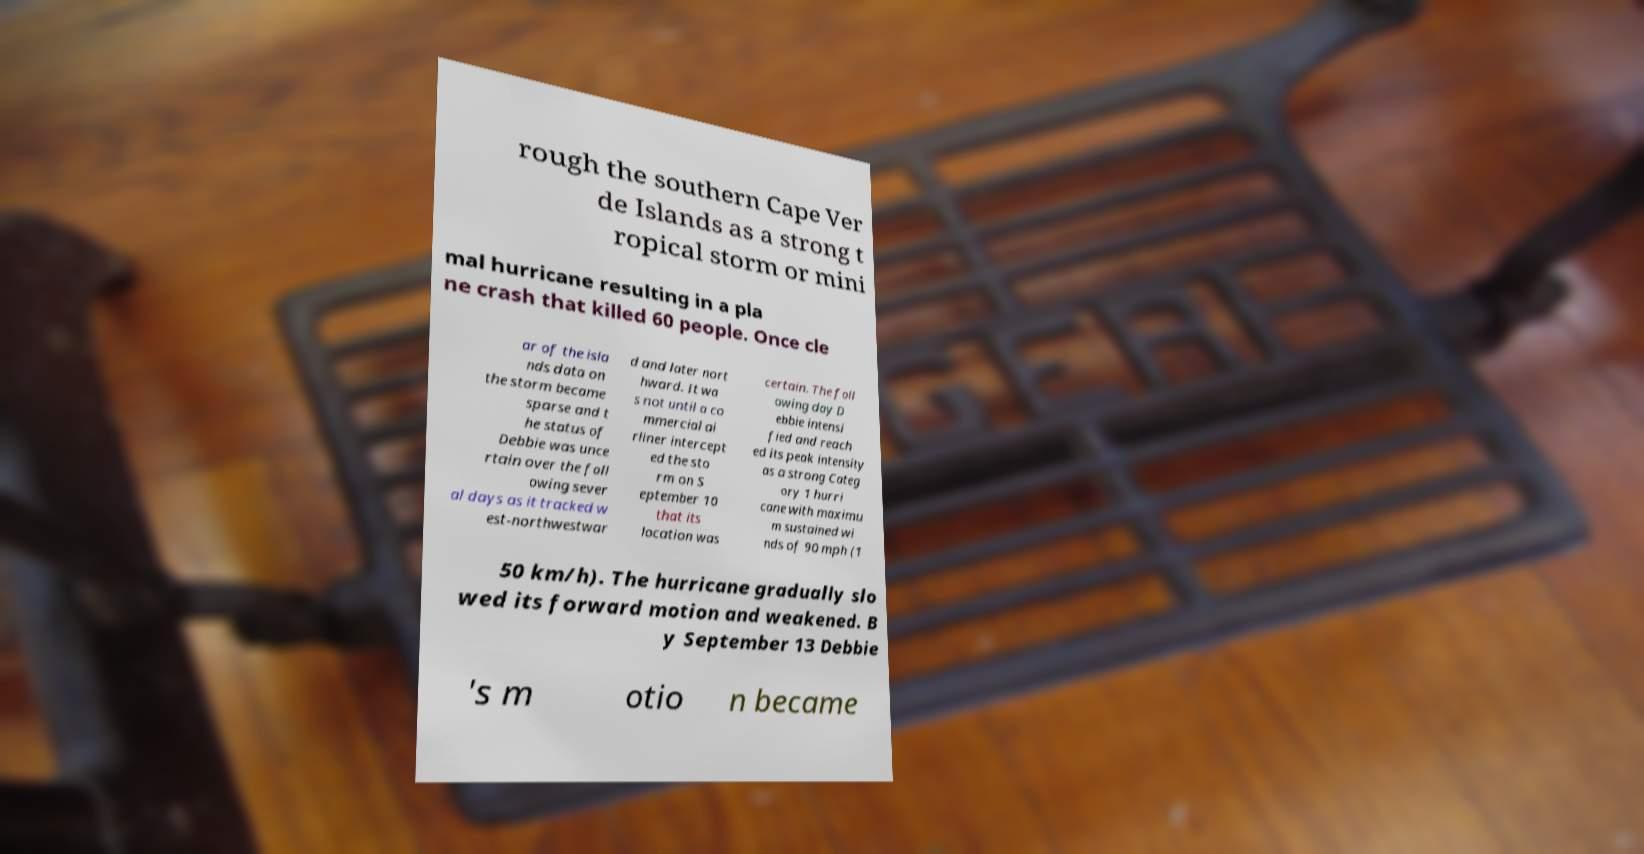I need the written content from this picture converted into text. Can you do that? rough the southern Cape Ver de Islands as a strong t ropical storm or mini mal hurricane resulting in a pla ne crash that killed 60 people. Once cle ar of the isla nds data on the storm became sparse and t he status of Debbie was unce rtain over the foll owing sever al days as it tracked w est-northwestwar d and later nort hward. It wa s not until a co mmercial ai rliner intercept ed the sto rm on S eptember 10 that its location was certain. The foll owing day D ebbie intensi fied and reach ed its peak intensity as a strong Categ ory 1 hurri cane with maximu m sustained wi nds of 90 mph (1 50 km/h). The hurricane gradually slo wed its forward motion and weakened. B y September 13 Debbie 's m otio n became 